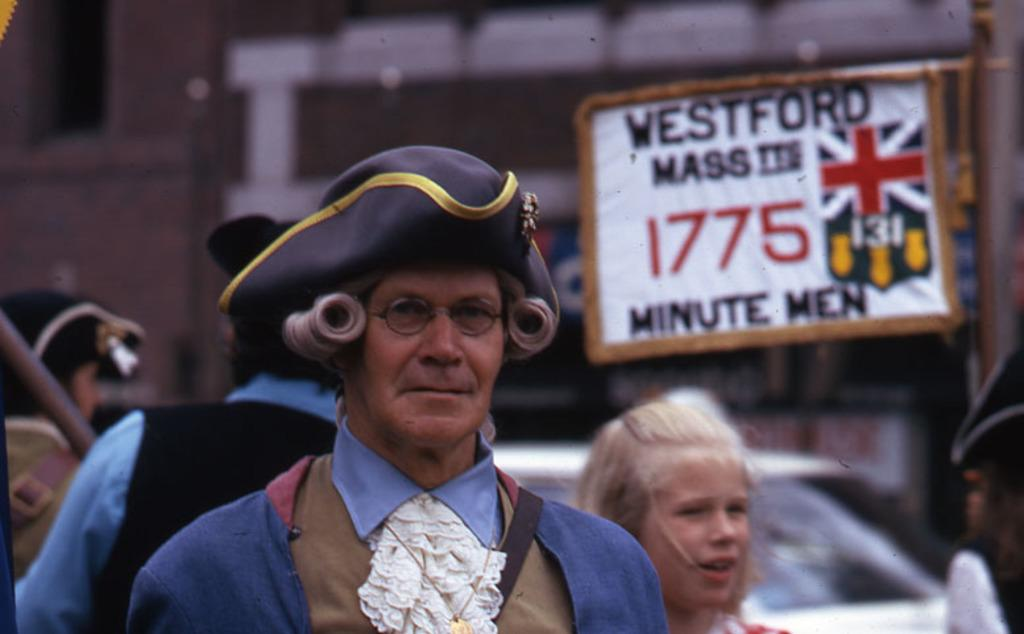What is the main subject in the foreground of the picture? There is a person in traditional costume in the foreground of the picture. Are there any other people visible in the image? Yes, there are people behind the person in traditional costume. What can be seen in the background of the picture? There is a vehicle in the background of the picture. What is present on the right side of the picture? There is a broad on the right side of the picture. How would you describe the background of the image? The background of the image is blurred. What time of day is it in the image, and what caused the person in traditional costume to wear a bag? There is no information about the time of day in the image, and the person in traditional costume is not wearing a bag. 